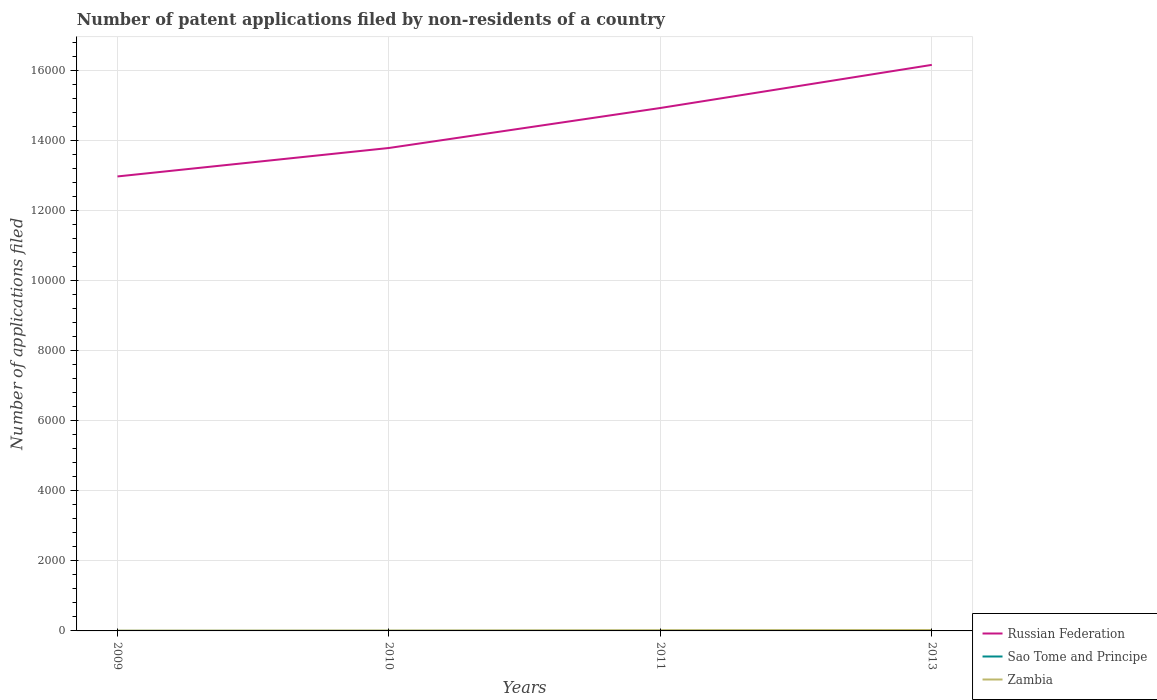How many different coloured lines are there?
Ensure brevity in your answer.  3. Does the line corresponding to Zambia intersect with the line corresponding to Russian Federation?
Your answer should be compact. No. Is the number of lines equal to the number of legend labels?
Your answer should be very brief. Yes. Across all years, what is the maximum number of applications filed in Russian Federation?
Make the answer very short. 1.30e+04. In which year was the number of applications filed in Russian Federation maximum?
Ensure brevity in your answer.  2009. What is the difference between the highest and the lowest number of applications filed in Russian Federation?
Give a very brief answer. 2. How many lines are there?
Offer a terse response. 3. How many years are there in the graph?
Your answer should be compact. 4. Does the graph contain any zero values?
Provide a short and direct response. No. How are the legend labels stacked?
Keep it short and to the point. Vertical. What is the title of the graph?
Offer a very short reply. Number of patent applications filed by non-residents of a country. Does "Guinea" appear as one of the legend labels in the graph?
Keep it short and to the point. No. What is the label or title of the Y-axis?
Keep it short and to the point. Number of applications filed. What is the Number of applications filed in Russian Federation in 2009?
Provide a short and direct response. 1.30e+04. What is the Number of applications filed of Zambia in 2009?
Provide a short and direct response. 9. What is the Number of applications filed of Russian Federation in 2010?
Keep it short and to the point. 1.38e+04. What is the Number of applications filed of Russian Federation in 2011?
Offer a terse response. 1.49e+04. What is the Number of applications filed in Zambia in 2011?
Keep it short and to the point. 21. What is the Number of applications filed in Russian Federation in 2013?
Give a very brief answer. 1.61e+04. Across all years, what is the maximum Number of applications filed in Russian Federation?
Provide a succinct answer. 1.61e+04. Across all years, what is the minimum Number of applications filed of Russian Federation?
Keep it short and to the point. 1.30e+04. Across all years, what is the minimum Number of applications filed in Zambia?
Offer a terse response. 9. What is the total Number of applications filed in Russian Federation in the graph?
Ensure brevity in your answer.  5.78e+04. What is the total Number of applications filed of Sao Tome and Principe in the graph?
Your answer should be very brief. 12. What is the total Number of applications filed in Zambia in the graph?
Give a very brief answer. 68. What is the difference between the Number of applications filed of Russian Federation in 2009 and that in 2010?
Your answer should be very brief. -812. What is the difference between the Number of applications filed of Zambia in 2009 and that in 2010?
Give a very brief answer. -3. What is the difference between the Number of applications filed of Russian Federation in 2009 and that in 2011?
Offer a terse response. -1953. What is the difference between the Number of applications filed of Zambia in 2009 and that in 2011?
Ensure brevity in your answer.  -12. What is the difference between the Number of applications filed of Russian Federation in 2009 and that in 2013?
Keep it short and to the point. -3183. What is the difference between the Number of applications filed of Sao Tome and Principe in 2009 and that in 2013?
Offer a terse response. -7. What is the difference between the Number of applications filed of Russian Federation in 2010 and that in 2011?
Give a very brief answer. -1141. What is the difference between the Number of applications filed of Russian Federation in 2010 and that in 2013?
Provide a short and direct response. -2371. What is the difference between the Number of applications filed of Sao Tome and Principe in 2010 and that in 2013?
Provide a succinct answer. -7. What is the difference between the Number of applications filed of Zambia in 2010 and that in 2013?
Make the answer very short. -14. What is the difference between the Number of applications filed in Russian Federation in 2011 and that in 2013?
Provide a succinct answer. -1230. What is the difference between the Number of applications filed in Sao Tome and Principe in 2011 and that in 2013?
Your answer should be very brief. -6. What is the difference between the Number of applications filed in Zambia in 2011 and that in 2013?
Ensure brevity in your answer.  -5. What is the difference between the Number of applications filed of Russian Federation in 2009 and the Number of applications filed of Sao Tome and Principe in 2010?
Your answer should be compact. 1.30e+04. What is the difference between the Number of applications filed of Russian Federation in 2009 and the Number of applications filed of Zambia in 2010?
Provide a succinct answer. 1.30e+04. What is the difference between the Number of applications filed of Sao Tome and Principe in 2009 and the Number of applications filed of Zambia in 2010?
Make the answer very short. -11. What is the difference between the Number of applications filed in Russian Federation in 2009 and the Number of applications filed in Sao Tome and Principe in 2011?
Your answer should be very brief. 1.30e+04. What is the difference between the Number of applications filed in Russian Federation in 2009 and the Number of applications filed in Zambia in 2011?
Your answer should be compact. 1.29e+04. What is the difference between the Number of applications filed in Sao Tome and Principe in 2009 and the Number of applications filed in Zambia in 2011?
Ensure brevity in your answer.  -20. What is the difference between the Number of applications filed in Russian Federation in 2009 and the Number of applications filed in Sao Tome and Principe in 2013?
Offer a very short reply. 1.30e+04. What is the difference between the Number of applications filed of Russian Federation in 2009 and the Number of applications filed of Zambia in 2013?
Give a very brief answer. 1.29e+04. What is the difference between the Number of applications filed in Russian Federation in 2010 and the Number of applications filed in Sao Tome and Principe in 2011?
Give a very brief answer. 1.38e+04. What is the difference between the Number of applications filed of Russian Federation in 2010 and the Number of applications filed of Zambia in 2011?
Keep it short and to the point. 1.38e+04. What is the difference between the Number of applications filed of Russian Federation in 2010 and the Number of applications filed of Sao Tome and Principe in 2013?
Your answer should be compact. 1.38e+04. What is the difference between the Number of applications filed in Russian Federation in 2010 and the Number of applications filed in Zambia in 2013?
Offer a terse response. 1.38e+04. What is the difference between the Number of applications filed of Russian Federation in 2011 and the Number of applications filed of Sao Tome and Principe in 2013?
Your response must be concise. 1.49e+04. What is the difference between the Number of applications filed in Russian Federation in 2011 and the Number of applications filed in Zambia in 2013?
Give a very brief answer. 1.49e+04. What is the difference between the Number of applications filed of Sao Tome and Principe in 2011 and the Number of applications filed of Zambia in 2013?
Keep it short and to the point. -24. What is the average Number of applications filed of Russian Federation per year?
Your answer should be very brief. 1.45e+04. What is the average Number of applications filed in Sao Tome and Principe per year?
Give a very brief answer. 3. What is the average Number of applications filed in Zambia per year?
Ensure brevity in your answer.  17. In the year 2009, what is the difference between the Number of applications filed of Russian Federation and Number of applications filed of Sao Tome and Principe?
Your response must be concise. 1.30e+04. In the year 2009, what is the difference between the Number of applications filed of Russian Federation and Number of applications filed of Zambia?
Your answer should be compact. 1.30e+04. In the year 2009, what is the difference between the Number of applications filed in Sao Tome and Principe and Number of applications filed in Zambia?
Your answer should be very brief. -8. In the year 2010, what is the difference between the Number of applications filed in Russian Federation and Number of applications filed in Sao Tome and Principe?
Offer a very short reply. 1.38e+04. In the year 2010, what is the difference between the Number of applications filed of Russian Federation and Number of applications filed of Zambia?
Ensure brevity in your answer.  1.38e+04. In the year 2010, what is the difference between the Number of applications filed of Sao Tome and Principe and Number of applications filed of Zambia?
Provide a succinct answer. -11. In the year 2011, what is the difference between the Number of applications filed of Russian Federation and Number of applications filed of Sao Tome and Principe?
Your answer should be very brief. 1.49e+04. In the year 2011, what is the difference between the Number of applications filed of Russian Federation and Number of applications filed of Zambia?
Offer a very short reply. 1.49e+04. In the year 2011, what is the difference between the Number of applications filed of Sao Tome and Principe and Number of applications filed of Zambia?
Give a very brief answer. -19. In the year 2013, what is the difference between the Number of applications filed of Russian Federation and Number of applications filed of Sao Tome and Principe?
Keep it short and to the point. 1.61e+04. In the year 2013, what is the difference between the Number of applications filed in Russian Federation and Number of applications filed in Zambia?
Your answer should be compact. 1.61e+04. What is the ratio of the Number of applications filed in Russian Federation in 2009 to that in 2010?
Offer a terse response. 0.94. What is the ratio of the Number of applications filed of Sao Tome and Principe in 2009 to that in 2010?
Make the answer very short. 1. What is the ratio of the Number of applications filed of Zambia in 2009 to that in 2010?
Ensure brevity in your answer.  0.75. What is the ratio of the Number of applications filed of Russian Federation in 2009 to that in 2011?
Give a very brief answer. 0.87. What is the ratio of the Number of applications filed of Sao Tome and Principe in 2009 to that in 2011?
Provide a succinct answer. 0.5. What is the ratio of the Number of applications filed in Zambia in 2009 to that in 2011?
Your answer should be compact. 0.43. What is the ratio of the Number of applications filed of Russian Federation in 2009 to that in 2013?
Give a very brief answer. 0.8. What is the ratio of the Number of applications filed of Zambia in 2009 to that in 2013?
Provide a succinct answer. 0.35. What is the ratio of the Number of applications filed in Russian Federation in 2010 to that in 2011?
Make the answer very short. 0.92. What is the ratio of the Number of applications filed of Russian Federation in 2010 to that in 2013?
Keep it short and to the point. 0.85. What is the ratio of the Number of applications filed in Sao Tome and Principe in 2010 to that in 2013?
Provide a succinct answer. 0.12. What is the ratio of the Number of applications filed of Zambia in 2010 to that in 2013?
Your answer should be very brief. 0.46. What is the ratio of the Number of applications filed in Russian Federation in 2011 to that in 2013?
Keep it short and to the point. 0.92. What is the ratio of the Number of applications filed in Sao Tome and Principe in 2011 to that in 2013?
Your answer should be very brief. 0.25. What is the ratio of the Number of applications filed of Zambia in 2011 to that in 2013?
Provide a succinct answer. 0.81. What is the difference between the highest and the second highest Number of applications filed in Russian Federation?
Your response must be concise. 1230. What is the difference between the highest and the second highest Number of applications filed of Sao Tome and Principe?
Your answer should be very brief. 6. What is the difference between the highest and the second highest Number of applications filed of Zambia?
Offer a very short reply. 5. What is the difference between the highest and the lowest Number of applications filed of Russian Federation?
Your answer should be very brief. 3183. What is the difference between the highest and the lowest Number of applications filed in Sao Tome and Principe?
Your response must be concise. 7. 